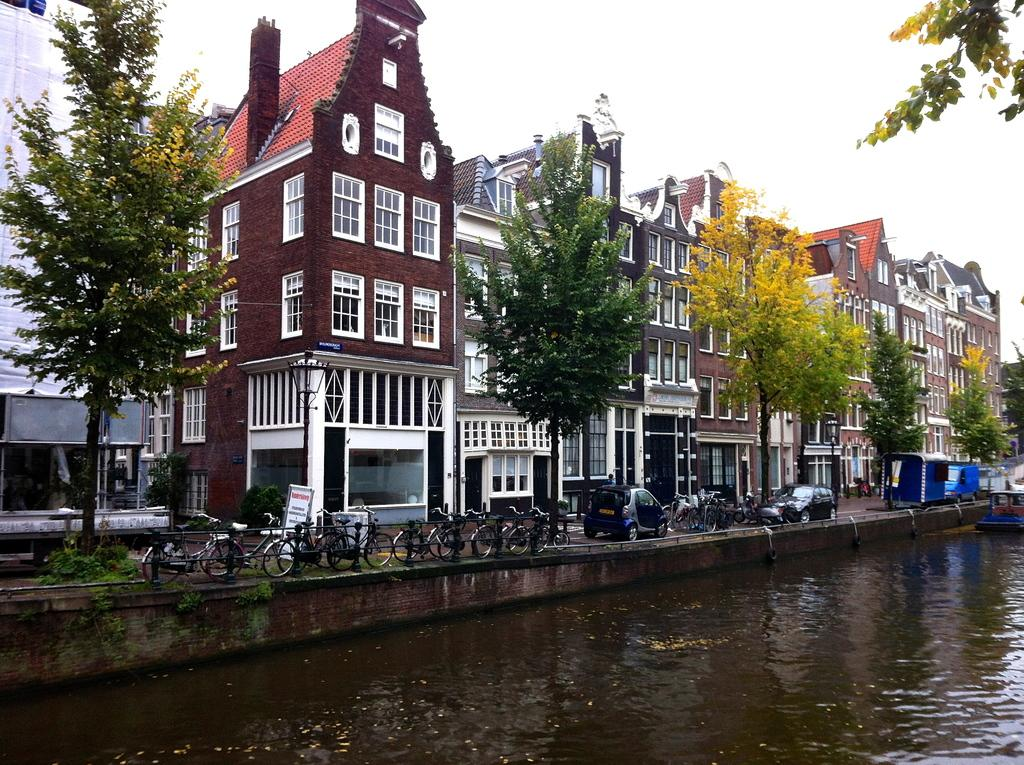What body of water is visible in the image? There is a lake in the image. What is located near the lake? There is a road beside the lake. What types of vehicles can be seen on the road? Cars and bicycles are present on the road. What can be seen in the background of the image? There are trees and houses in the background of the image. What type of wire can be seen connecting the trees in the image? There is no wire connecting the trees in the image; only the lake, road, vehicles, and background are present. 